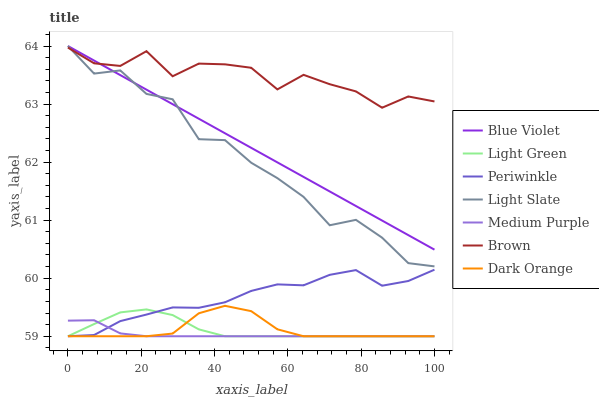Does Dark Orange have the minimum area under the curve?
Answer yes or no. No. Does Dark Orange have the maximum area under the curve?
Answer yes or no. No. Is Dark Orange the smoothest?
Answer yes or no. No. Is Dark Orange the roughest?
Answer yes or no. No. Does Light Slate have the lowest value?
Answer yes or no. No. Does Dark Orange have the highest value?
Answer yes or no. No. Is Dark Orange less than Blue Violet?
Answer yes or no. Yes. Is Blue Violet greater than Light Green?
Answer yes or no. Yes. Does Dark Orange intersect Blue Violet?
Answer yes or no. No. 